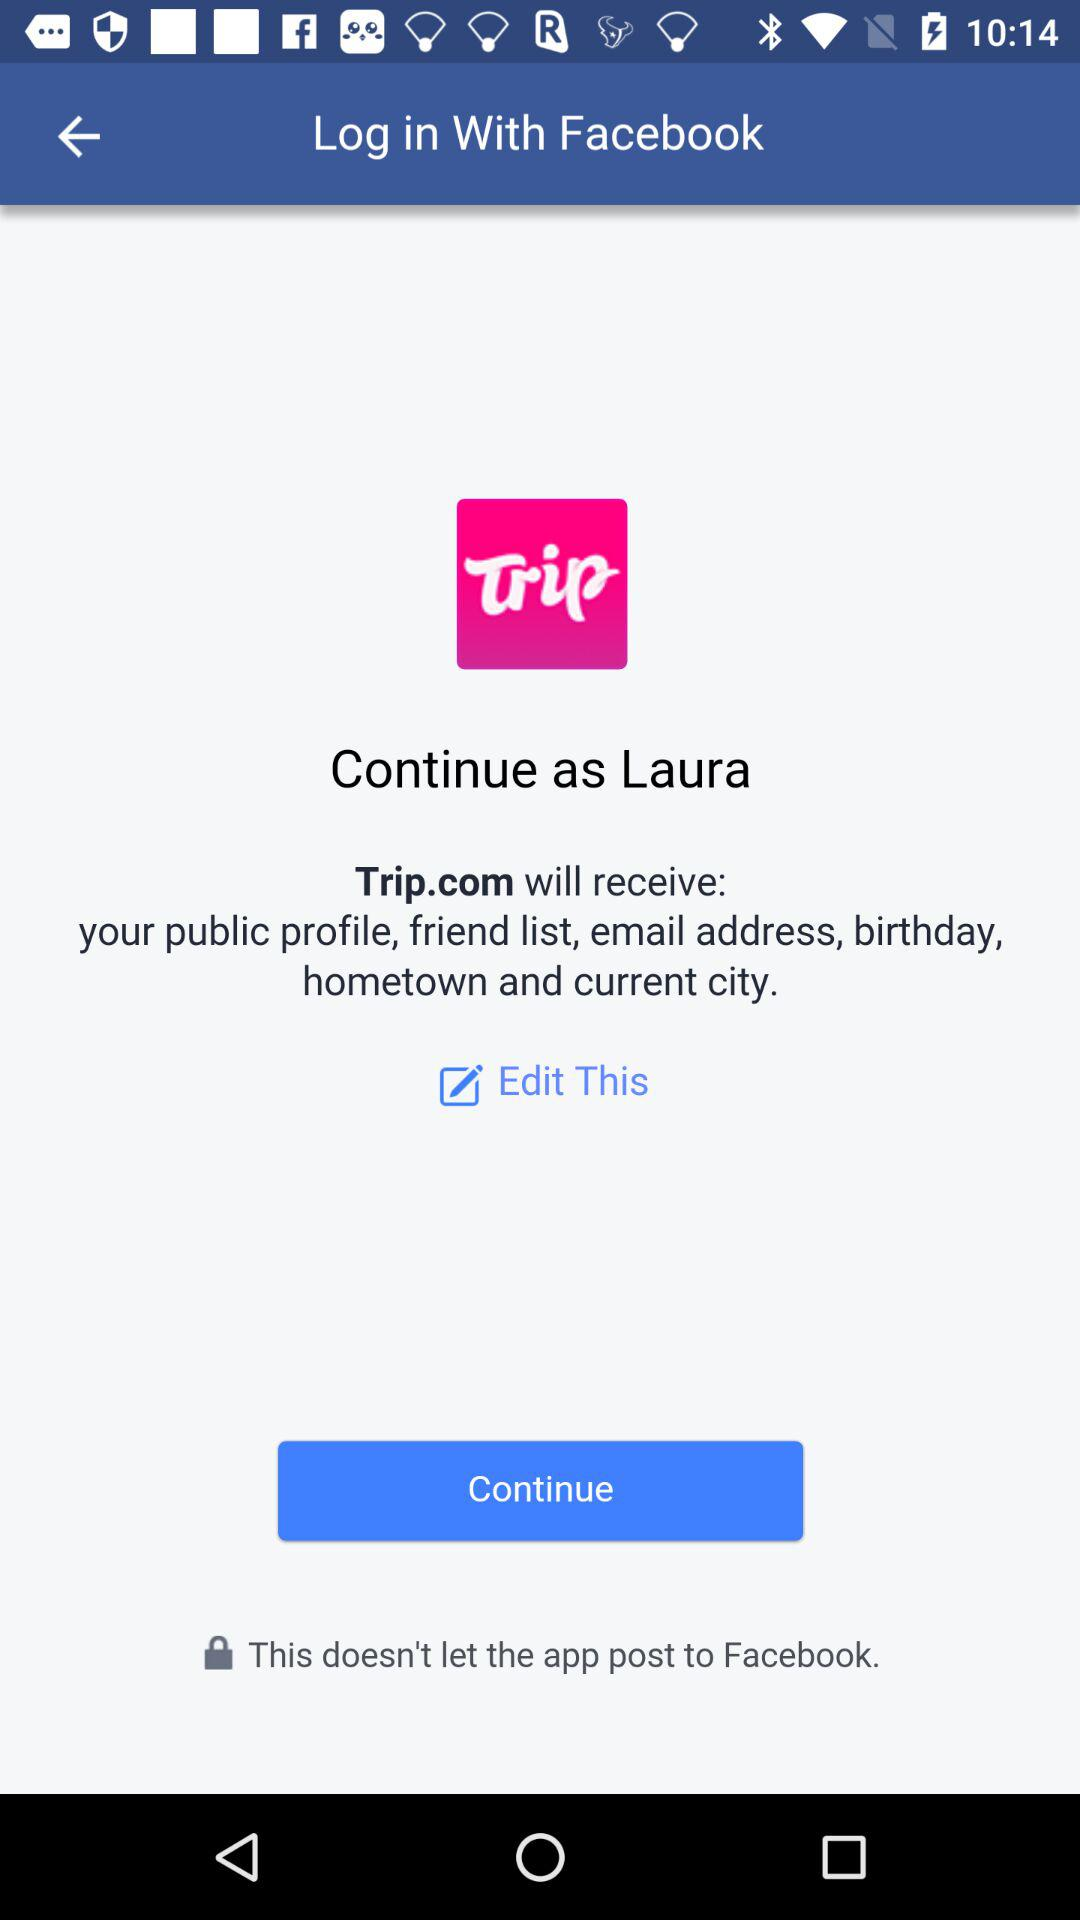Who will receive the public profile, email address, friend list, birthday, hometown and current city? The application "Trip.com" will receive the public profile, email address, friend list, birthday, hometown and current city. 